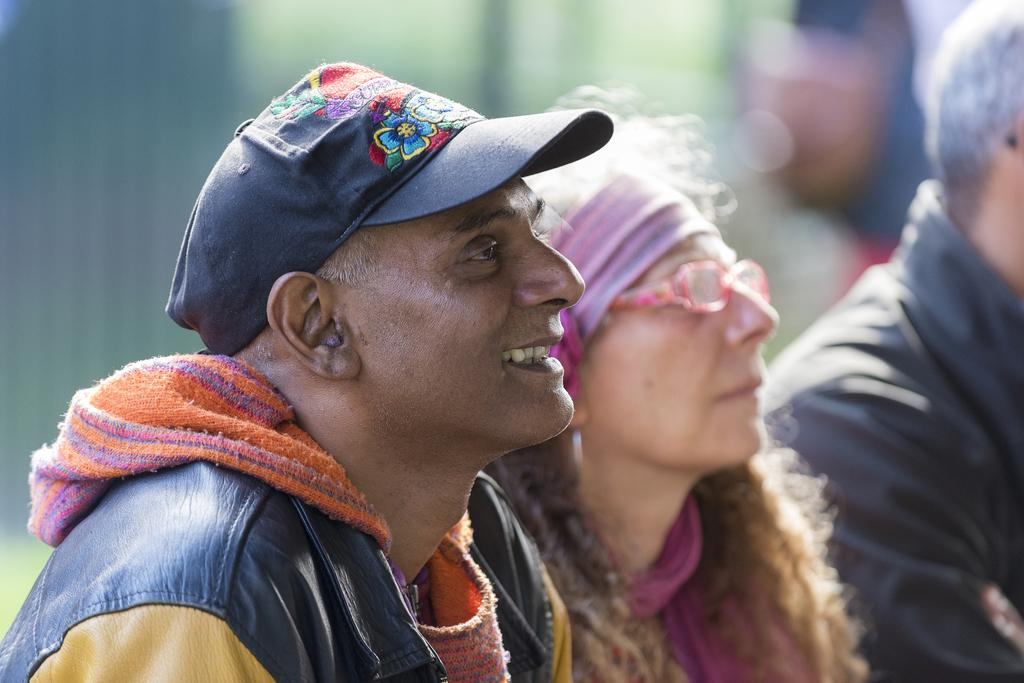Who can be seen in the image? There are people in the image. Can you describe the clothing of one of the individuals? A man is wearing a cap and a jacket in the image. How would you describe the quality of the image's background? The image is blurry in the background. What book is the cat reading in the image? There is no cat or book present in the image. 